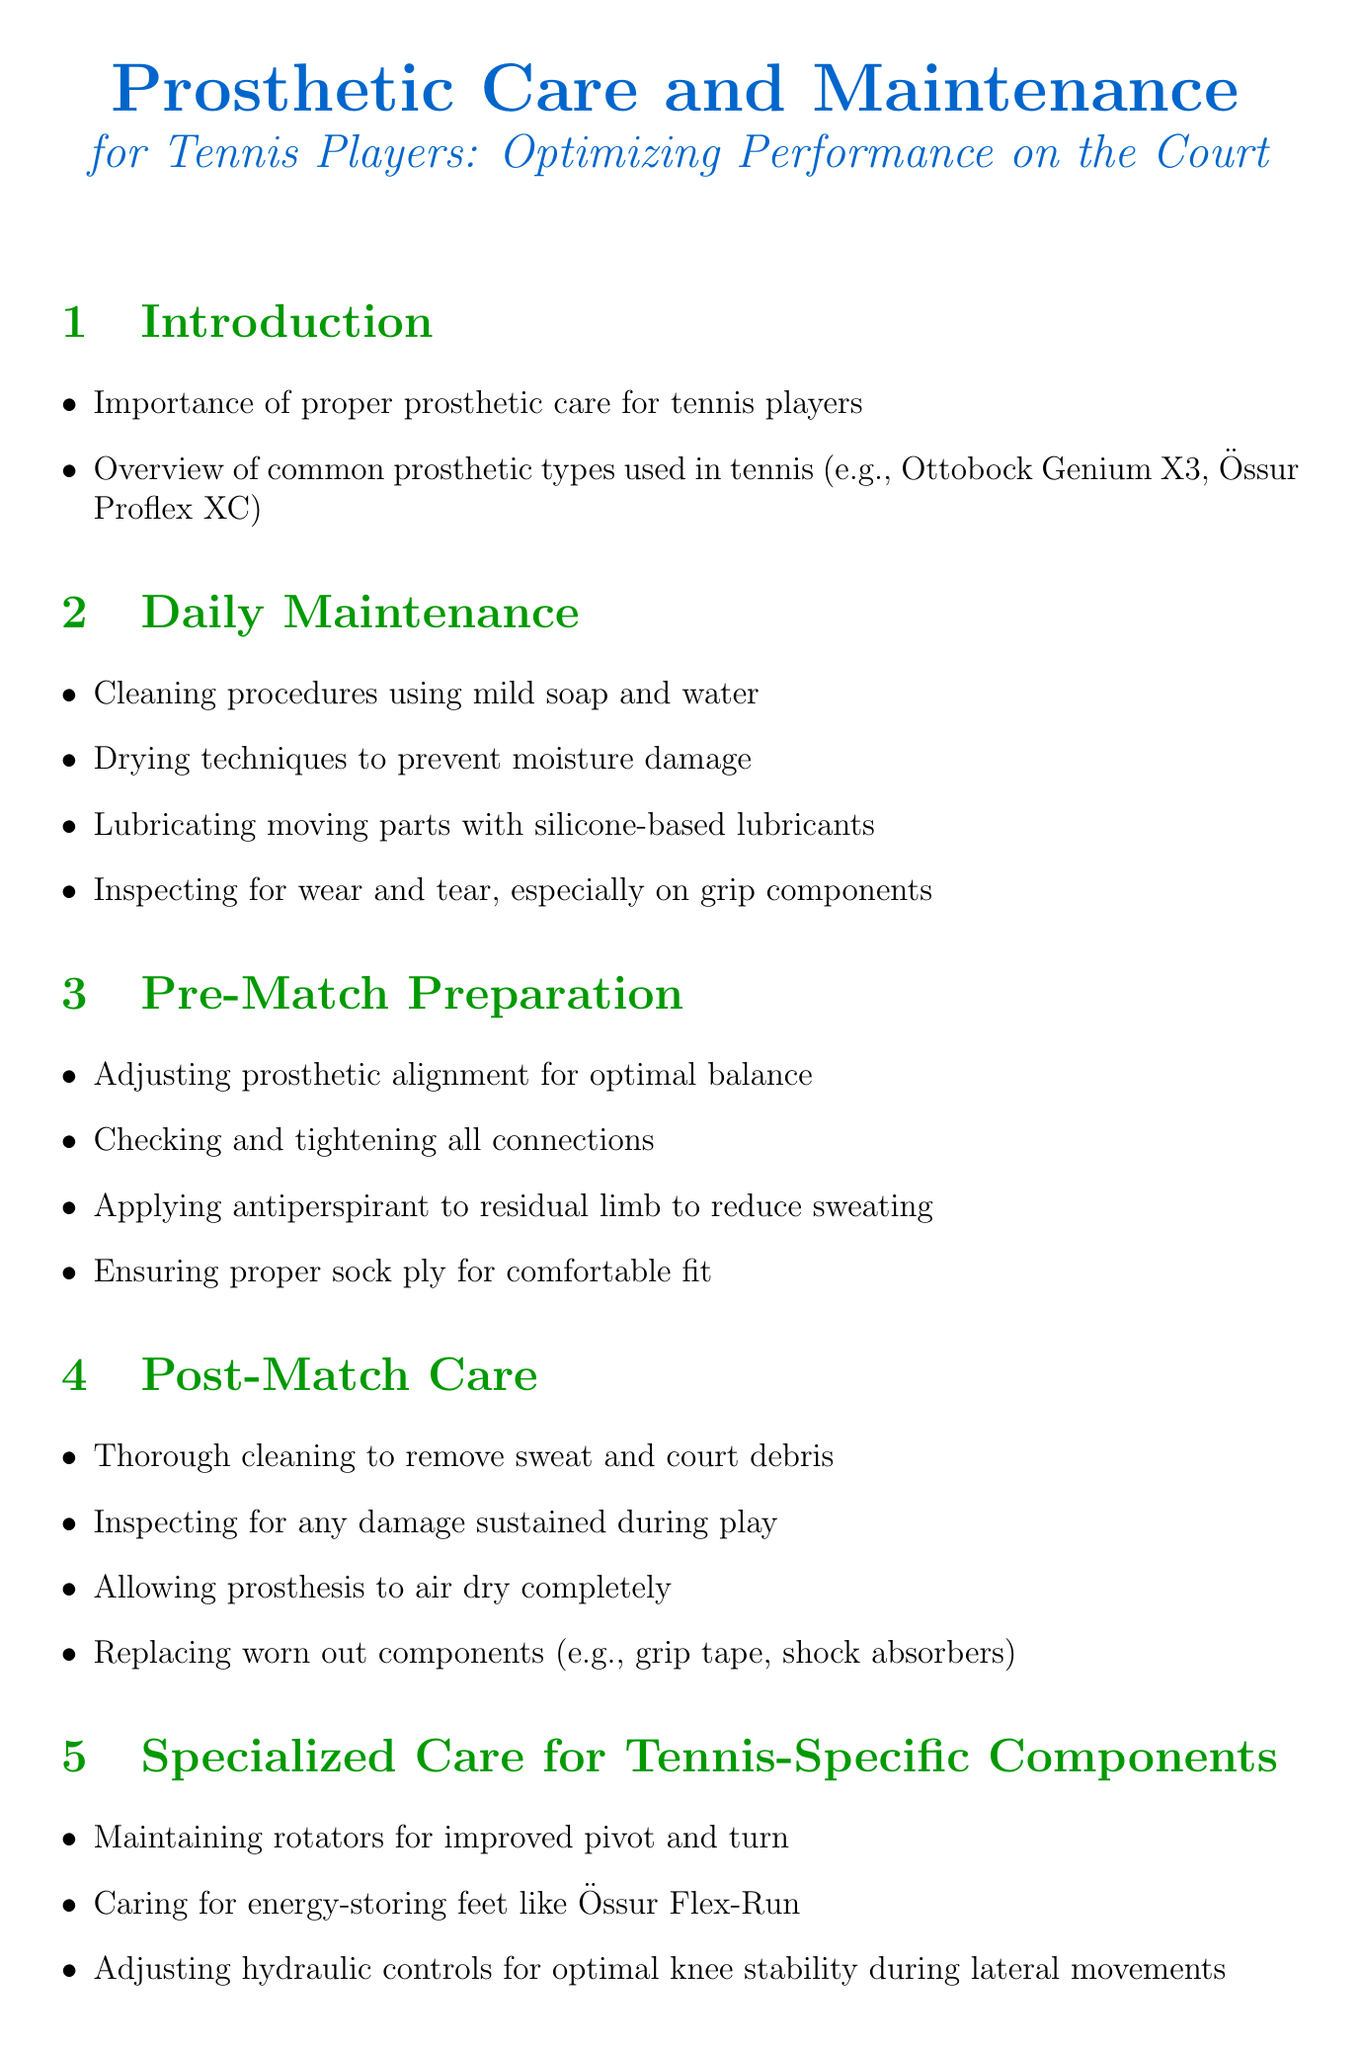what is the title of the document? The title of the document is provided at the beginning and is "Prosthetic Care and Maintenance for Tennis Players: Optimizing Performance on the Court."
Answer: Prosthetic Care and Maintenance for Tennis Players: Optimizing Performance on the Court what is the primary focus of the introduction section? The introduction section discusses the importance of proper prosthetic care for tennis players and provides an overview of common prosthetic types used in tennis.
Answer: Importance of proper prosthetic care for tennis players what must be checked during pre-match preparation? The pre-match preparation includes adjusting prosthetic alignment for optimal balance, checking and tightening all connections, and ensuring proper sock ply for comfortable fit.
Answer: Adjusting prosthetic alignment for optimal balance how often should regular check-ups with a prosthetist be scheduled? The document mentions that regular check-ups with a prosthetist should be scheduled as part of long-term maintenance to ensure optimal performance.
Answer: Regularly what should be used to lubricate moving parts of the prosthesis? The document suggests using silicone-based lubricants for lubricating moving parts of the prosthesis during daily maintenance.
Answer: Silicone-based lubricants what is one issue addressed in the section on common tennis-related issues? The document addresses preventing and treating skin irritations from intense activity as one common issue related to playing tennis with a prosthesis.
Answer: Preventing and treating skin irritations what is an important aspect of post-match care for prosthetics? The post-match care emphasizes thorough cleaning to remove sweat and court debris and inspecting for any damage sustained during play.
Answer: Thorough cleaning to remove sweat and court debris what type of socks should be selected for tennis? The document mentions the importance of selecting appropriate prosthetic socks for different activity levels as part of adaptive equipment and accessories.
Answer: Appropriate prosthetic socks what component should be maintained for improved pivot and turn? The specialized care section highlights the need for maintaining rotators to improve pivot and turn during tennis activities.
Answer: Rotators 